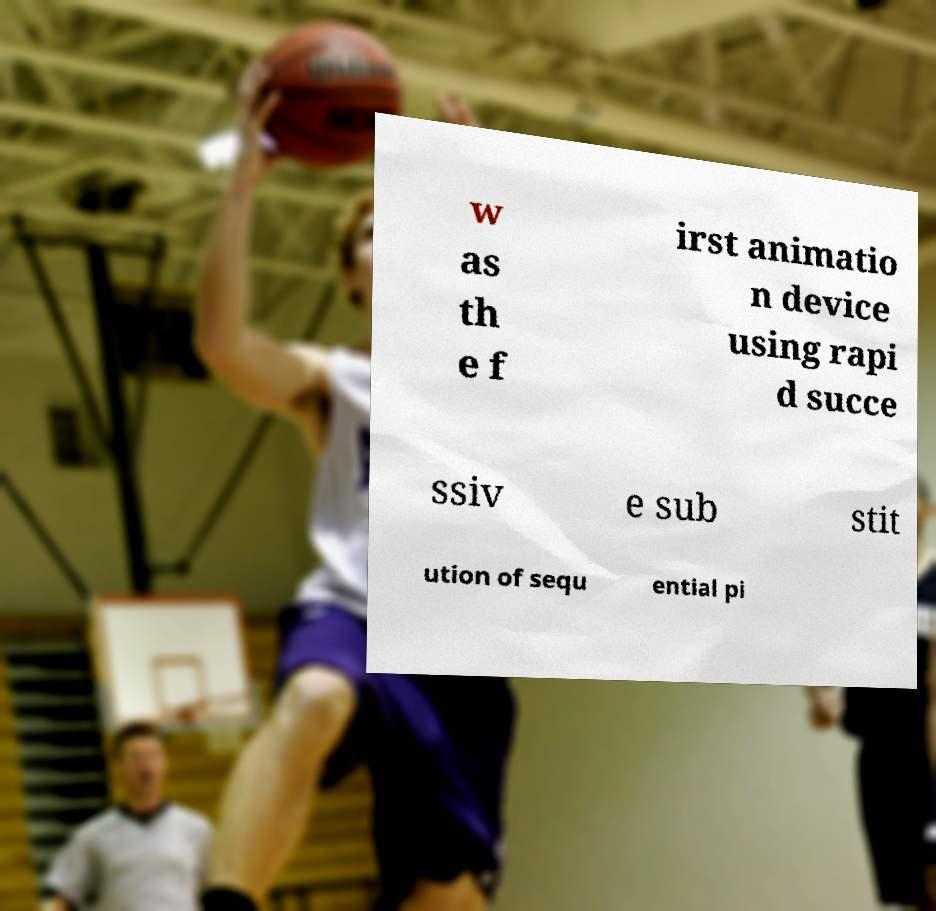Can you read and provide the text displayed in the image?This photo seems to have some interesting text. Can you extract and type it out for me? w as th e f irst animatio n device using rapi d succe ssiv e sub stit ution of sequ ential pi 